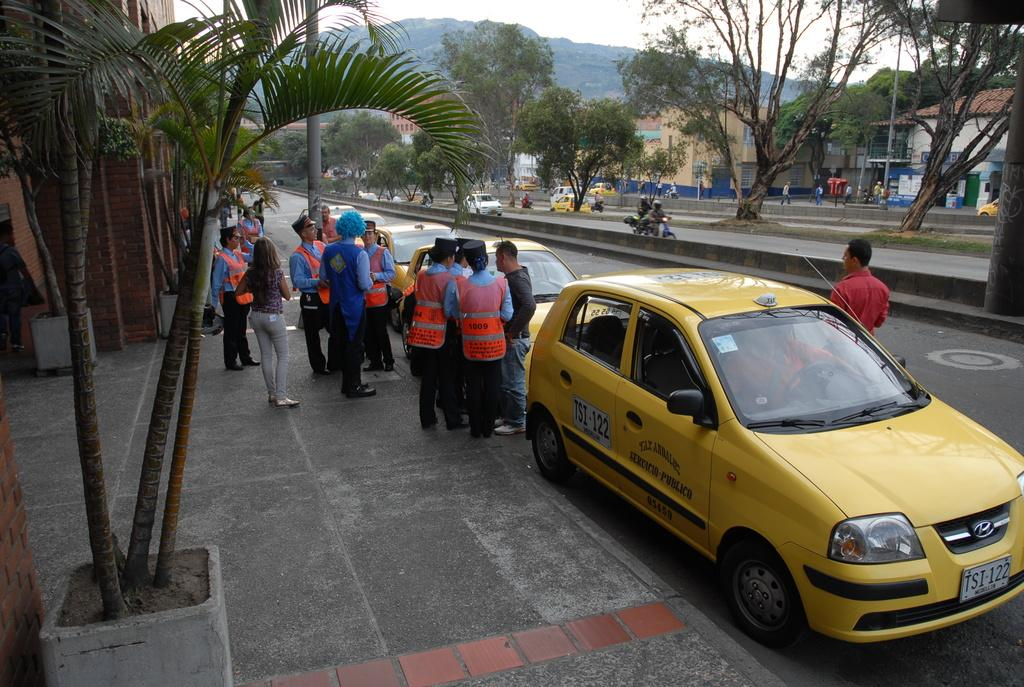<image>
Write a terse but informative summary of the picture. Some people in high visibility jackets stand about; one of them has the number 1009 on the back. 